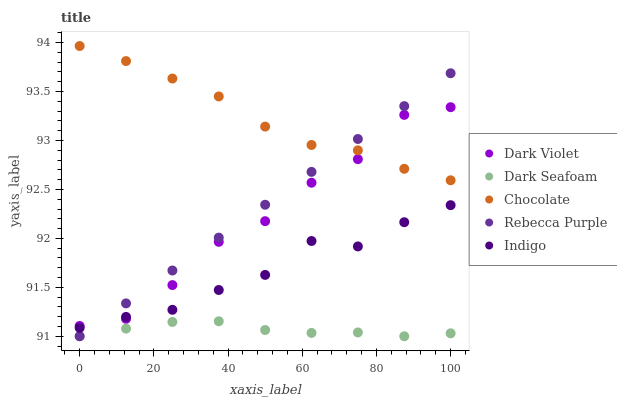Does Dark Seafoam have the minimum area under the curve?
Answer yes or no. Yes. Does Chocolate have the maximum area under the curve?
Answer yes or no. Yes. Does Indigo have the minimum area under the curve?
Answer yes or no. No. Does Indigo have the maximum area under the curve?
Answer yes or no. No. Is Rebecca Purple the smoothest?
Answer yes or no. Yes. Is Dark Violet the roughest?
Answer yes or no. Yes. Is Indigo the smoothest?
Answer yes or no. No. Is Indigo the roughest?
Answer yes or no. No. Does Dark Seafoam have the lowest value?
Answer yes or no. Yes. Does Indigo have the lowest value?
Answer yes or no. No. Does Chocolate have the highest value?
Answer yes or no. Yes. Does Indigo have the highest value?
Answer yes or no. No. Is Dark Seafoam less than Dark Violet?
Answer yes or no. Yes. Is Dark Violet greater than Dark Seafoam?
Answer yes or no. Yes. Does Indigo intersect Rebecca Purple?
Answer yes or no. Yes. Is Indigo less than Rebecca Purple?
Answer yes or no. No. Is Indigo greater than Rebecca Purple?
Answer yes or no. No. Does Dark Seafoam intersect Dark Violet?
Answer yes or no. No. 